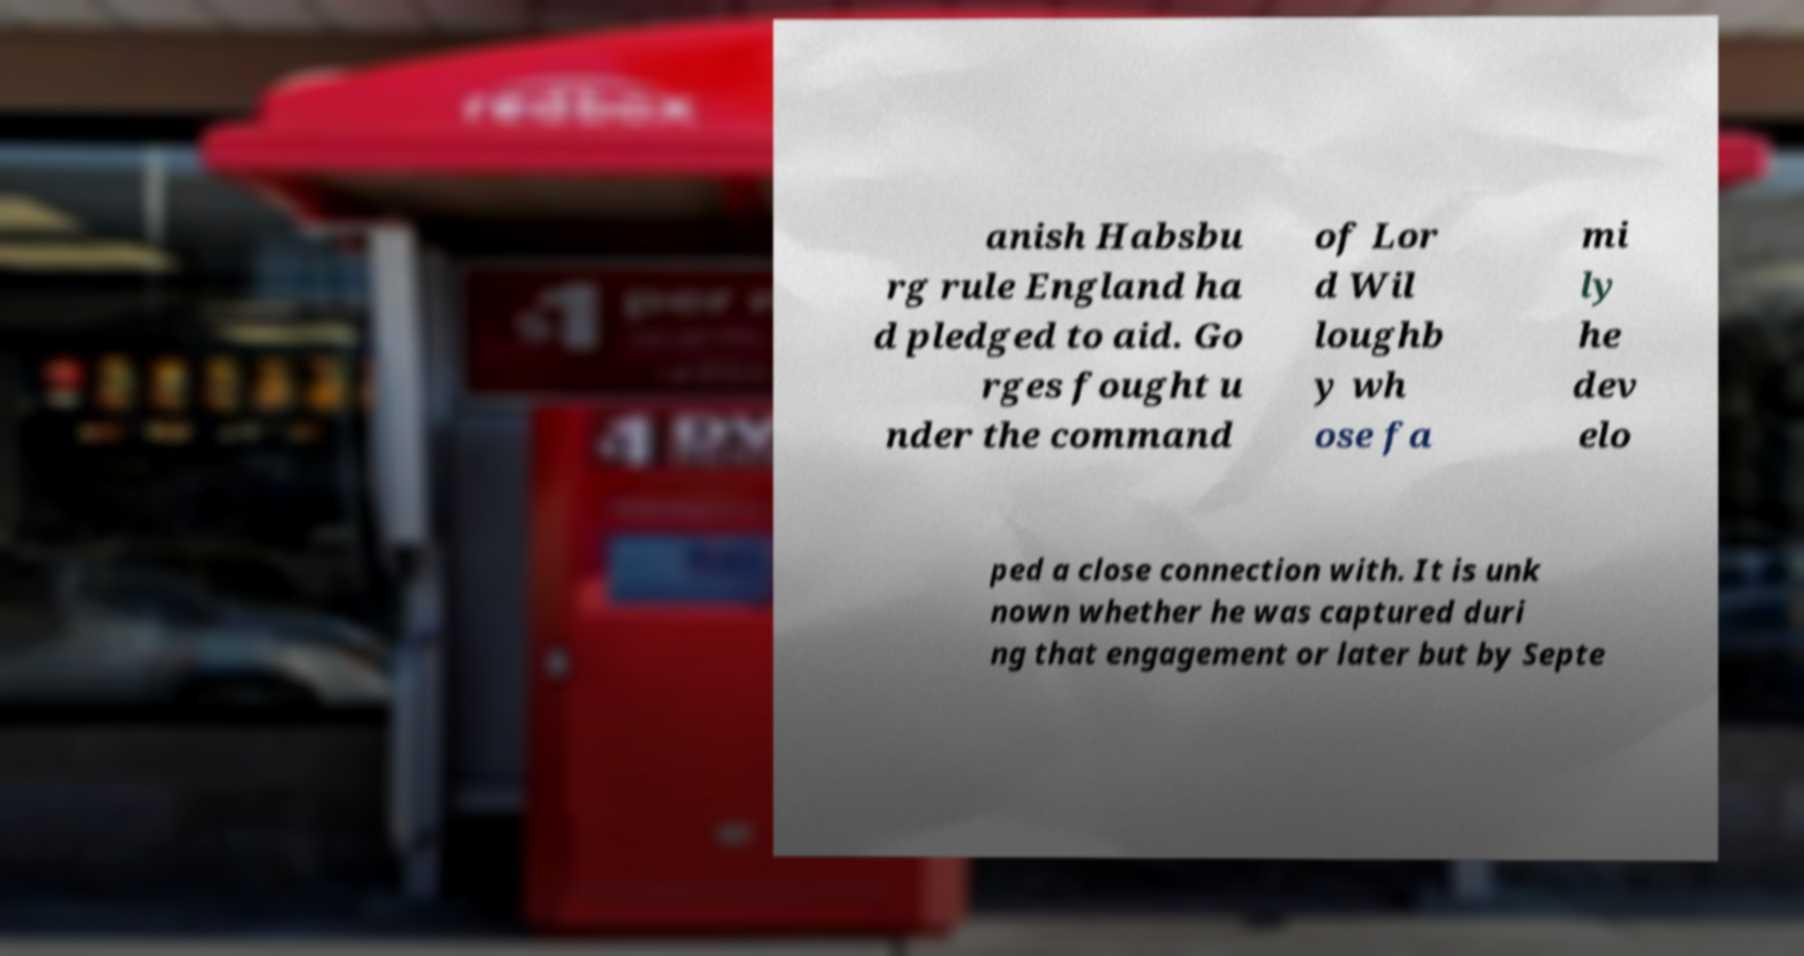What messages or text are displayed in this image? I need them in a readable, typed format. anish Habsbu rg rule England ha d pledged to aid. Go rges fought u nder the command of Lor d Wil loughb y wh ose fa mi ly he dev elo ped a close connection with. It is unk nown whether he was captured duri ng that engagement or later but by Septe 